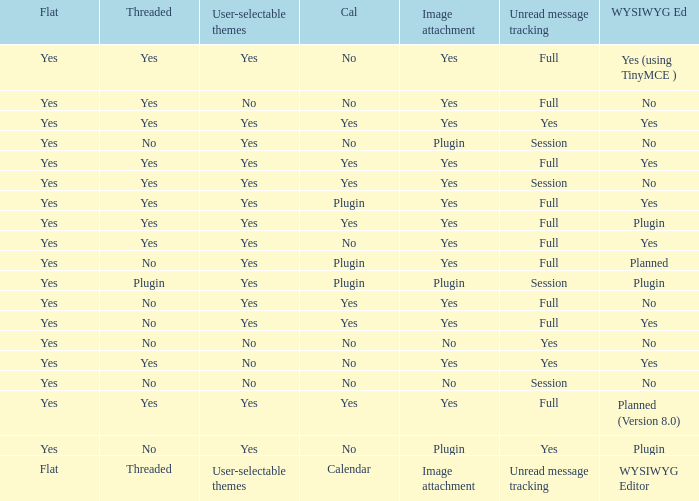Which Calendar has a WYSIWYG Editor of no, and an Unread message tracking of session, and an Image attachment of no? No. Would you be able to parse every entry in this table? {'header': ['Flat', 'Threaded', 'User-selectable themes', 'Cal', 'Image attachment', 'Unread message tracking', 'WYSIWYG Ed'], 'rows': [['Yes', 'Yes', 'Yes', 'No', 'Yes', 'Full', 'Yes (using TinyMCE )'], ['Yes', 'Yes', 'No', 'No', 'Yes', 'Full', 'No'], ['Yes', 'Yes', 'Yes', 'Yes', 'Yes', 'Yes', 'Yes'], ['Yes', 'No', 'Yes', 'No', 'Plugin', 'Session', 'No'], ['Yes', 'Yes', 'Yes', 'Yes', 'Yes', 'Full', 'Yes'], ['Yes', 'Yes', 'Yes', 'Yes', 'Yes', 'Session', 'No'], ['Yes', 'Yes', 'Yes', 'Plugin', 'Yes', 'Full', 'Yes'], ['Yes', 'Yes', 'Yes', 'Yes', 'Yes', 'Full', 'Plugin'], ['Yes', 'Yes', 'Yes', 'No', 'Yes', 'Full', 'Yes'], ['Yes', 'No', 'Yes', 'Plugin', 'Yes', 'Full', 'Planned'], ['Yes', 'Plugin', 'Yes', 'Plugin', 'Plugin', 'Session', 'Plugin'], ['Yes', 'No', 'Yes', 'Yes', 'Yes', 'Full', 'No'], ['Yes', 'No', 'Yes', 'Yes', 'Yes', 'Full', 'Yes'], ['Yes', 'No', 'No', 'No', 'No', 'Yes', 'No'], ['Yes', 'Yes', 'No', 'No', 'Yes', 'Yes', 'Yes'], ['Yes', 'No', 'No', 'No', 'No', 'Session', 'No'], ['Yes', 'Yes', 'Yes', 'Yes', 'Yes', 'Full', 'Planned (Version 8.0)'], ['Yes', 'No', 'Yes', 'No', 'Plugin', 'Yes', 'Plugin'], ['Flat', 'Threaded', 'User-selectable themes', 'Calendar', 'Image attachment', 'Unread message tracking', 'WYSIWYG Editor']]} 